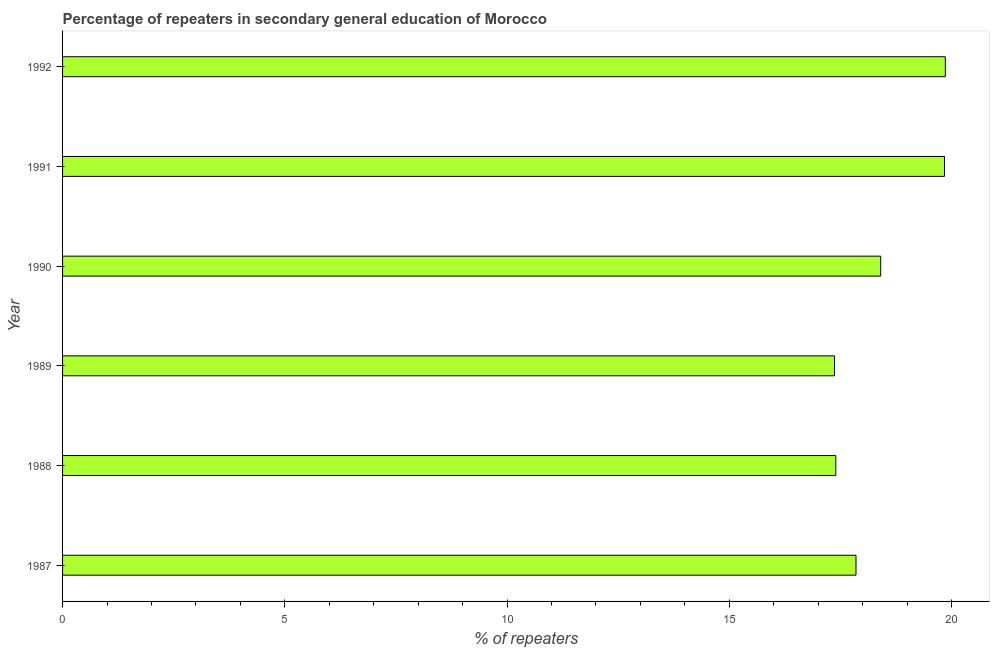Does the graph contain any zero values?
Your answer should be compact. No. Does the graph contain grids?
Keep it short and to the point. No. What is the title of the graph?
Give a very brief answer. Percentage of repeaters in secondary general education of Morocco. What is the label or title of the X-axis?
Offer a terse response. % of repeaters. What is the label or title of the Y-axis?
Your answer should be very brief. Year. What is the percentage of repeaters in 1989?
Offer a terse response. 17.37. Across all years, what is the maximum percentage of repeaters?
Ensure brevity in your answer.  19.86. Across all years, what is the minimum percentage of repeaters?
Offer a terse response. 17.37. In which year was the percentage of repeaters maximum?
Provide a succinct answer. 1992. In which year was the percentage of repeaters minimum?
Your response must be concise. 1989. What is the sum of the percentage of repeaters?
Offer a very short reply. 110.73. What is the difference between the percentage of repeaters in 1991 and 1992?
Your response must be concise. -0.02. What is the average percentage of repeaters per year?
Your response must be concise. 18.45. What is the median percentage of repeaters?
Provide a succinct answer. 18.13. Do a majority of the years between 1990 and 1989 (inclusive) have percentage of repeaters greater than 12 %?
Your answer should be very brief. No. What is the ratio of the percentage of repeaters in 1989 to that in 1990?
Your response must be concise. 0.94. Is the percentage of repeaters in 1988 less than that in 1992?
Ensure brevity in your answer.  Yes. Is the difference between the percentage of repeaters in 1989 and 1992 greater than the difference between any two years?
Give a very brief answer. Yes. What is the difference between the highest and the second highest percentage of repeaters?
Provide a succinct answer. 0.02. Is the sum of the percentage of repeaters in 1988 and 1991 greater than the maximum percentage of repeaters across all years?
Ensure brevity in your answer.  Yes. What is the difference between the highest and the lowest percentage of repeaters?
Give a very brief answer. 2.49. Are all the bars in the graph horizontal?
Your response must be concise. Yes. How many years are there in the graph?
Keep it short and to the point. 6. What is the % of repeaters of 1987?
Give a very brief answer. 17.85. What is the % of repeaters in 1988?
Your response must be concise. 17.4. What is the % of repeaters in 1989?
Your answer should be very brief. 17.37. What is the % of repeaters of 1990?
Your answer should be very brief. 18.41. What is the % of repeaters of 1991?
Your answer should be very brief. 19.84. What is the % of repeaters of 1992?
Provide a succinct answer. 19.86. What is the difference between the % of repeaters in 1987 and 1988?
Offer a terse response. 0.45. What is the difference between the % of repeaters in 1987 and 1989?
Provide a short and direct response. 0.48. What is the difference between the % of repeaters in 1987 and 1990?
Keep it short and to the point. -0.56. What is the difference between the % of repeaters in 1987 and 1991?
Make the answer very short. -1.99. What is the difference between the % of repeaters in 1987 and 1992?
Keep it short and to the point. -2.01. What is the difference between the % of repeaters in 1988 and 1989?
Offer a terse response. 0.03. What is the difference between the % of repeaters in 1988 and 1990?
Provide a short and direct response. -1.01. What is the difference between the % of repeaters in 1988 and 1991?
Your response must be concise. -2.45. What is the difference between the % of repeaters in 1988 and 1992?
Your answer should be compact. -2.46. What is the difference between the % of repeaters in 1989 and 1990?
Give a very brief answer. -1.04. What is the difference between the % of repeaters in 1989 and 1991?
Your answer should be compact. -2.47. What is the difference between the % of repeaters in 1989 and 1992?
Your answer should be very brief. -2.49. What is the difference between the % of repeaters in 1990 and 1991?
Give a very brief answer. -1.44. What is the difference between the % of repeaters in 1990 and 1992?
Offer a very short reply. -1.45. What is the difference between the % of repeaters in 1991 and 1992?
Provide a short and direct response. -0.02. What is the ratio of the % of repeaters in 1987 to that in 1988?
Give a very brief answer. 1.03. What is the ratio of the % of repeaters in 1987 to that in 1989?
Ensure brevity in your answer.  1.03. What is the ratio of the % of repeaters in 1987 to that in 1991?
Give a very brief answer. 0.9. What is the ratio of the % of repeaters in 1987 to that in 1992?
Provide a short and direct response. 0.9. What is the ratio of the % of repeaters in 1988 to that in 1989?
Ensure brevity in your answer.  1. What is the ratio of the % of repeaters in 1988 to that in 1990?
Offer a very short reply. 0.94. What is the ratio of the % of repeaters in 1988 to that in 1991?
Offer a terse response. 0.88. What is the ratio of the % of repeaters in 1988 to that in 1992?
Your answer should be very brief. 0.88. What is the ratio of the % of repeaters in 1989 to that in 1990?
Provide a succinct answer. 0.94. What is the ratio of the % of repeaters in 1989 to that in 1991?
Give a very brief answer. 0.88. What is the ratio of the % of repeaters in 1989 to that in 1992?
Offer a very short reply. 0.87. What is the ratio of the % of repeaters in 1990 to that in 1991?
Give a very brief answer. 0.93. What is the ratio of the % of repeaters in 1990 to that in 1992?
Ensure brevity in your answer.  0.93. What is the ratio of the % of repeaters in 1991 to that in 1992?
Provide a short and direct response. 1. 